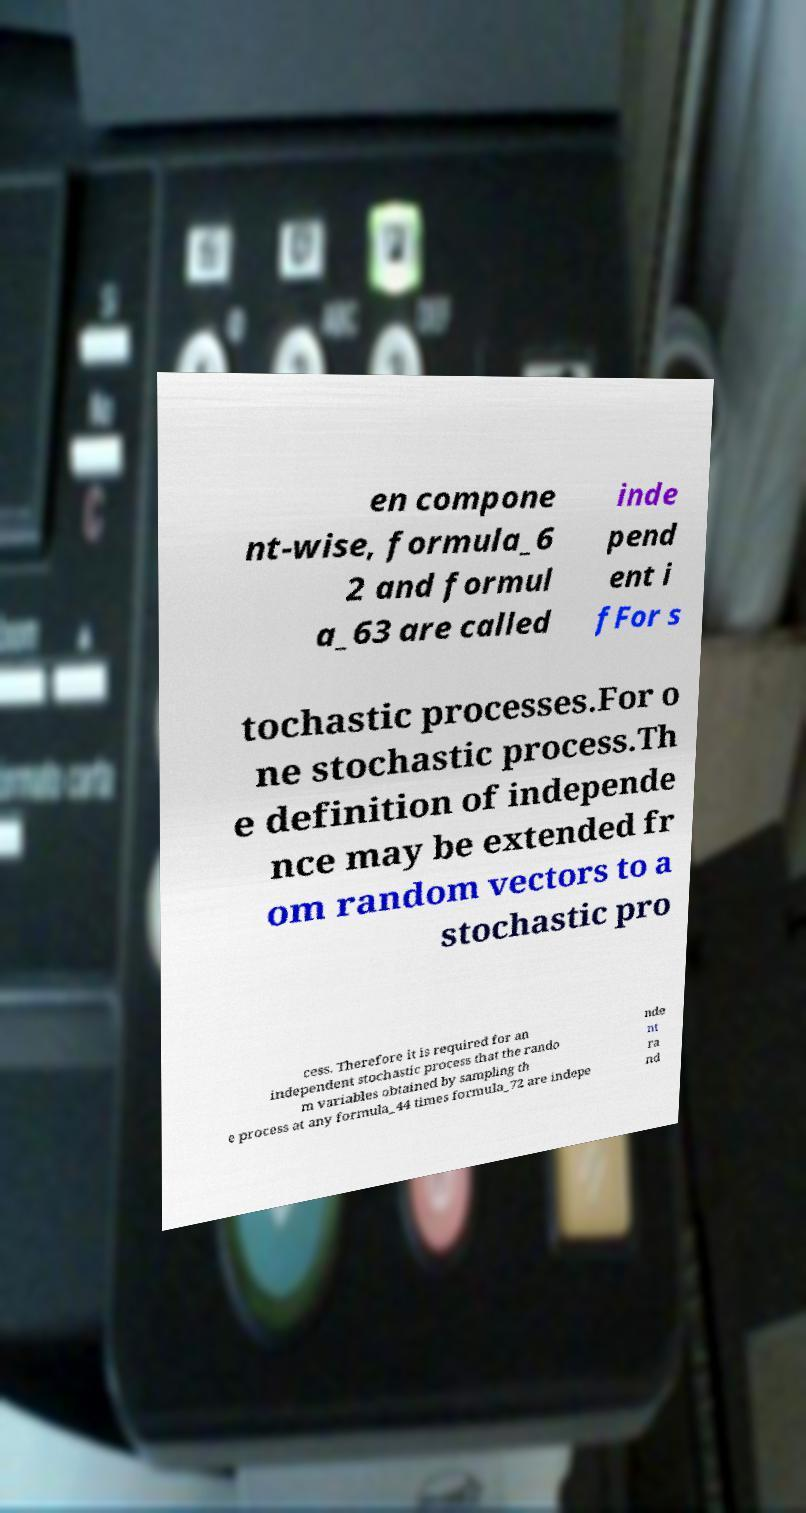What messages or text are displayed in this image? I need them in a readable, typed format. en compone nt-wise, formula_6 2 and formul a_63 are called inde pend ent i fFor s tochastic processes.For o ne stochastic process.Th e definition of independe nce may be extended fr om random vectors to a stochastic pro cess. Therefore it is required for an independent stochastic process that the rando m variables obtained by sampling th e process at any formula_44 times formula_72 are indepe nde nt ra nd 